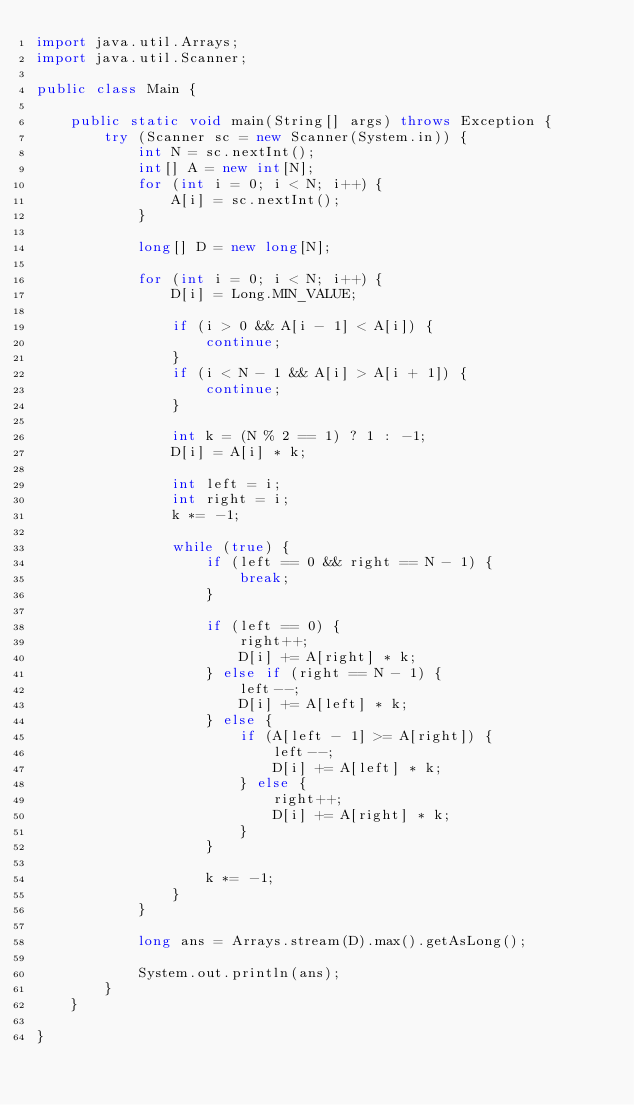Convert code to text. <code><loc_0><loc_0><loc_500><loc_500><_Java_>import java.util.Arrays;
import java.util.Scanner;

public class Main {

    public static void main(String[] args) throws Exception {
        try (Scanner sc = new Scanner(System.in)) {
            int N = sc.nextInt();
            int[] A = new int[N];
            for (int i = 0; i < N; i++) {
                A[i] = sc.nextInt();
            }

            long[] D = new long[N];

            for (int i = 0; i < N; i++) {
                D[i] = Long.MIN_VALUE;

                if (i > 0 && A[i - 1] < A[i]) {
                    continue;
                }
                if (i < N - 1 && A[i] > A[i + 1]) {
                    continue;
                }

                int k = (N % 2 == 1) ? 1 : -1;
                D[i] = A[i] * k;

                int left = i;
                int right = i;
                k *= -1;

                while (true) {
                    if (left == 0 && right == N - 1) {
                        break;
                    }

                    if (left == 0) {
                        right++;
                        D[i] += A[right] * k;
                    } else if (right == N - 1) {
                        left--;
                        D[i] += A[left] * k;
                    } else {
                        if (A[left - 1] >= A[right]) {
                            left--;
                            D[i] += A[left] * k;
                        } else {
                            right++;
                            D[i] += A[right] * k;
                        }
                    }

                    k *= -1;
                }
            }

            long ans = Arrays.stream(D).max().getAsLong();

            System.out.println(ans);
        }
    }

}
</code> 